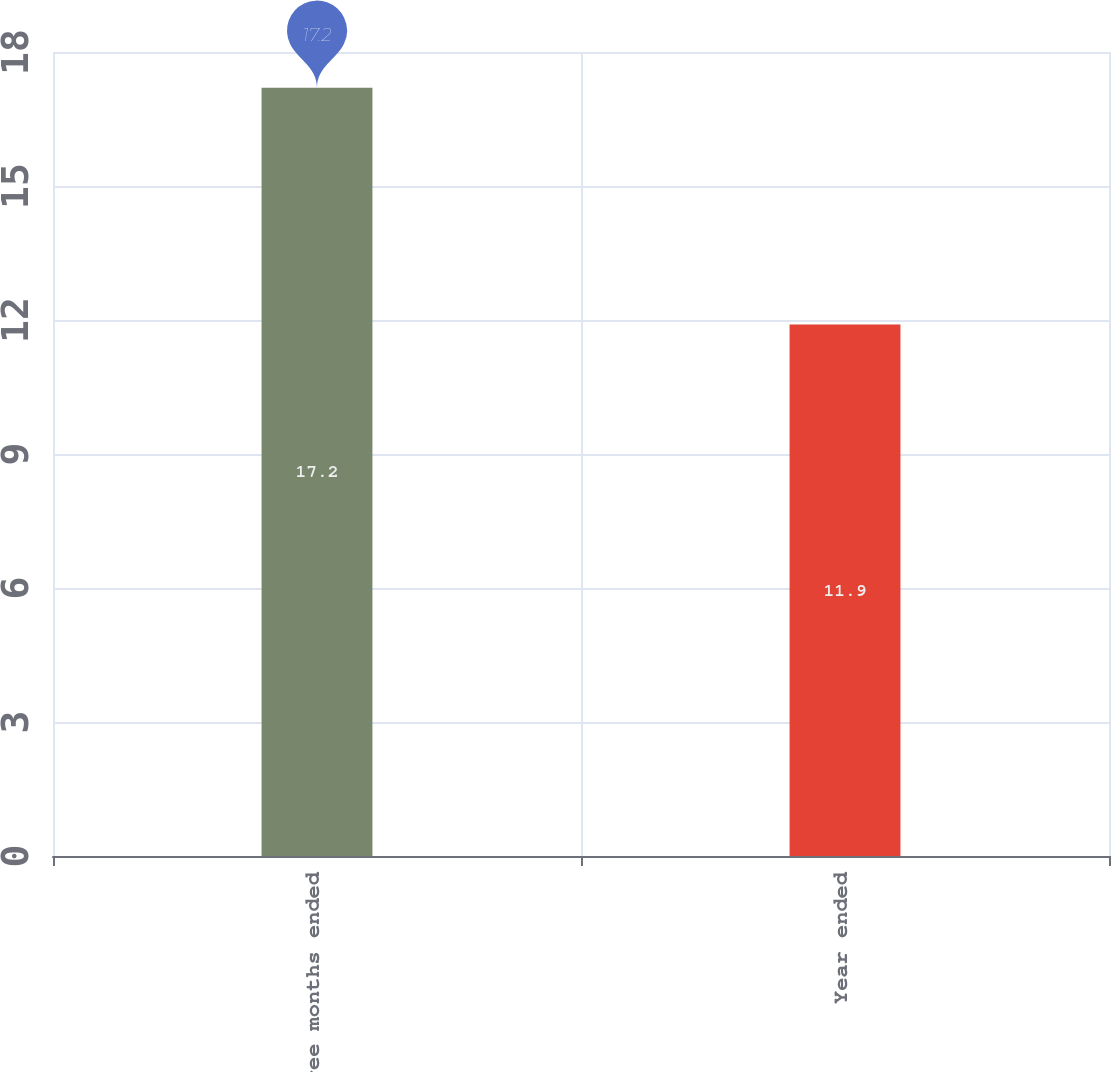<chart> <loc_0><loc_0><loc_500><loc_500><bar_chart><fcel>Three months ended<fcel>Year ended<nl><fcel>17.2<fcel>11.9<nl></chart> 